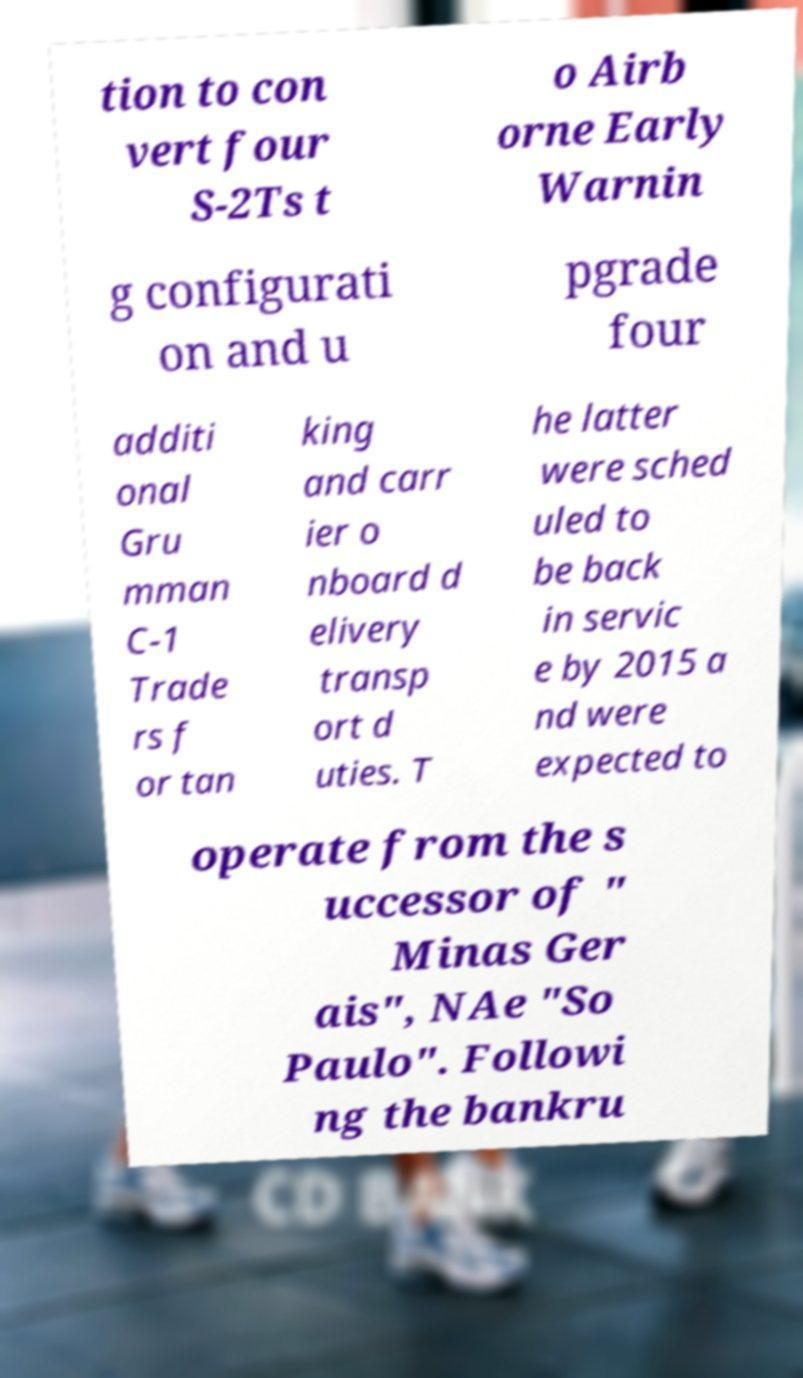Could you extract and type out the text from this image? tion to con vert four S-2Ts t o Airb orne Early Warnin g configurati on and u pgrade four additi onal Gru mman C-1 Trade rs f or tan king and carr ier o nboard d elivery transp ort d uties. T he latter were sched uled to be back in servic e by 2015 a nd were expected to operate from the s uccessor of " Minas Ger ais", NAe "So Paulo". Followi ng the bankru 